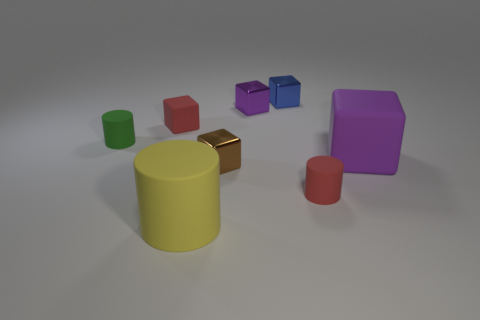Does the big cube have the same color as the small shiny object that is in front of the tiny green cylinder?
Offer a terse response. No. What size is the matte thing that is to the right of the large cylinder and left of the purple matte cube?
Your answer should be compact. Small. What number of other objects are there of the same color as the large matte block?
Your response must be concise. 1. There is a object on the left side of the small red thing on the left side of the tiny matte thing right of the large yellow cylinder; what size is it?
Your answer should be compact. Small. There is a small purple block; are there any tiny purple objects right of it?
Provide a succinct answer. No. Is the size of the red cylinder the same as the matte block that is right of the large yellow thing?
Provide a succinct answer. No. How many other things are made of the same material as the big purple object?
Give a very brief answer. 4. There is a small shiny object that is in front of the tiny blue object and behind the small brown cube; what shape is it?
Offer a terse response. Cube. Do the purple block in front of the red rubber block and the metallic object in front of the large purple cube have the same size?
Your response must be concise. No. There is a small purple thing that is made of the same material as the tiny brown block; what shape is it?
Offer a very short reply. Cube. 